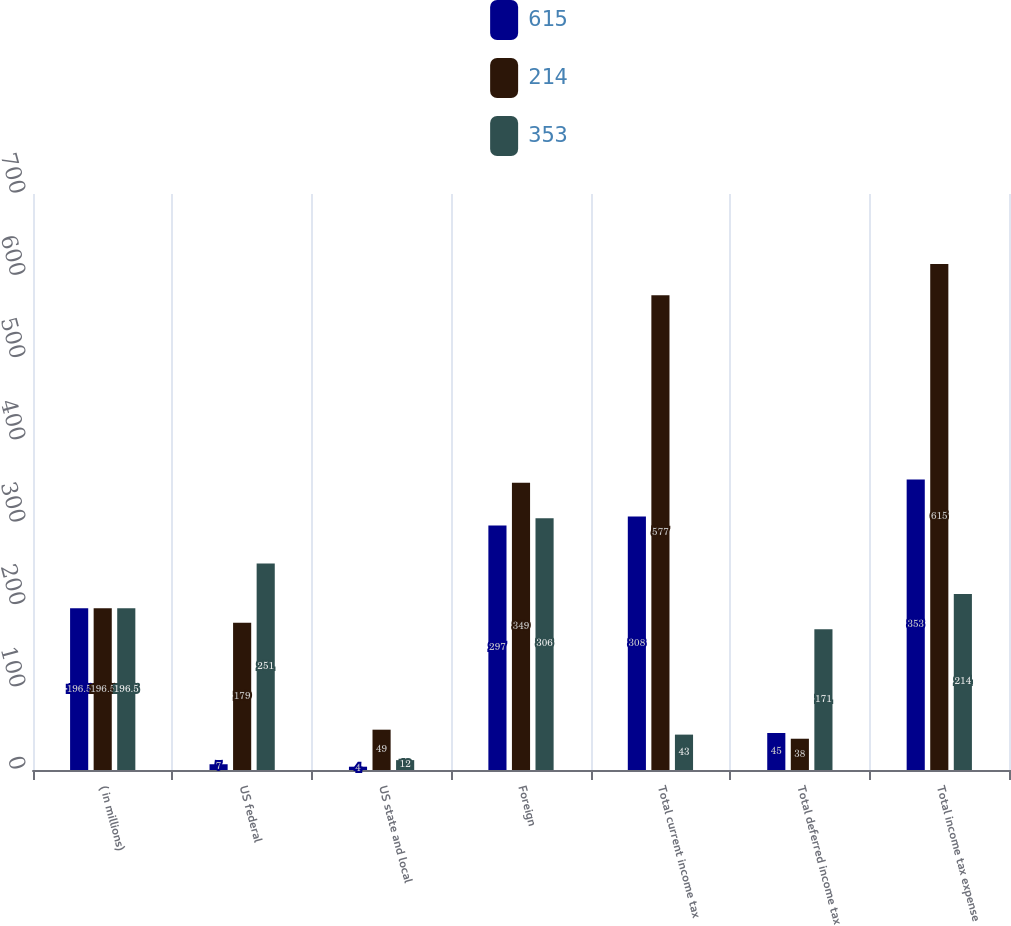Convert chart to OTSL. <chart><loc_0><loc_0><loc_500><loc_500><stacked_bar_chart><ecel><fcel>( in millions)<fcel>US federal<fcel>US state and local<fcel>Foreign<fcel>Total current income tax<fcel>Total deferred income tax<fcel>Total income tax expense<nl><fcel>615<fcel>196.5<fcel>7<fcel>4<fcel>297<fcel>308<fcel>45<fcel>353<nl><fcel>214<fcel>196.5<fcel>179<fcel>49<fcel>349<fcel>577<fcel>38<fcel>615<nl><fcel>353<fcel>196.5<fcel>251<fcel>12<fcel>306<fcel>43<fcel>171<fcel>214<nl></chart> 